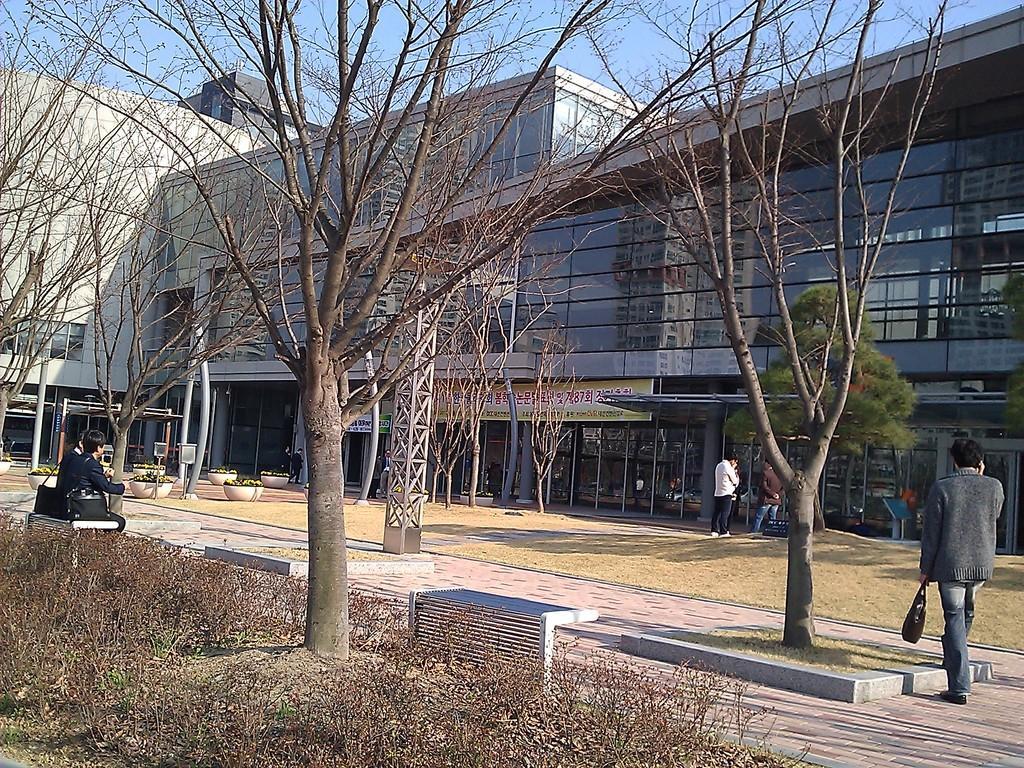Please provide a concise description of this image. In this picture I can see buildings and trees and few people are standing and a man holding a bag in his hand and speaking on a mobile and we see couple of them seated on the bench and i can see bags and few plants in the pots and grass and i can see a blue cloudy sky and I can see a board with some text. 